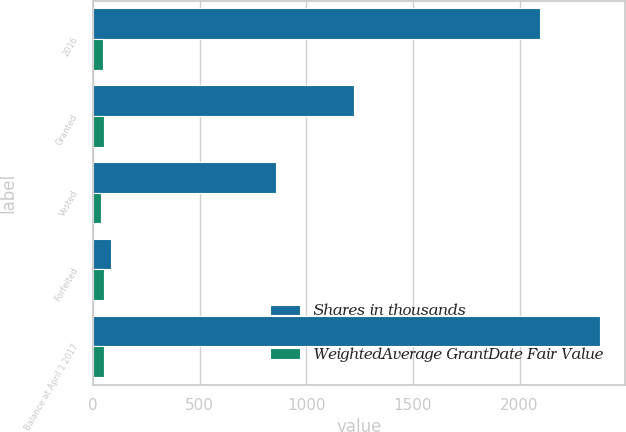Convert chart to OTSL. <chart><loc_0><loc_0><loc_500><loc_500><stacked_bar_chart><ecel><fcel>2016<fcel>Granted<fcel>Vested<fcel>Forfeited<fcel>Balance at April 1 2017<nl><fcel>Shares in thousands<fcel>2095<fcel>1223<fcel>857<fcel>86<fcel>2375<nl><fcel>WeightedAverage GrantDate Fair Value<fcel>47.09<fcel>52.8<fcel>37.59<fcel>53.1<fcel>53<nl></chart> 